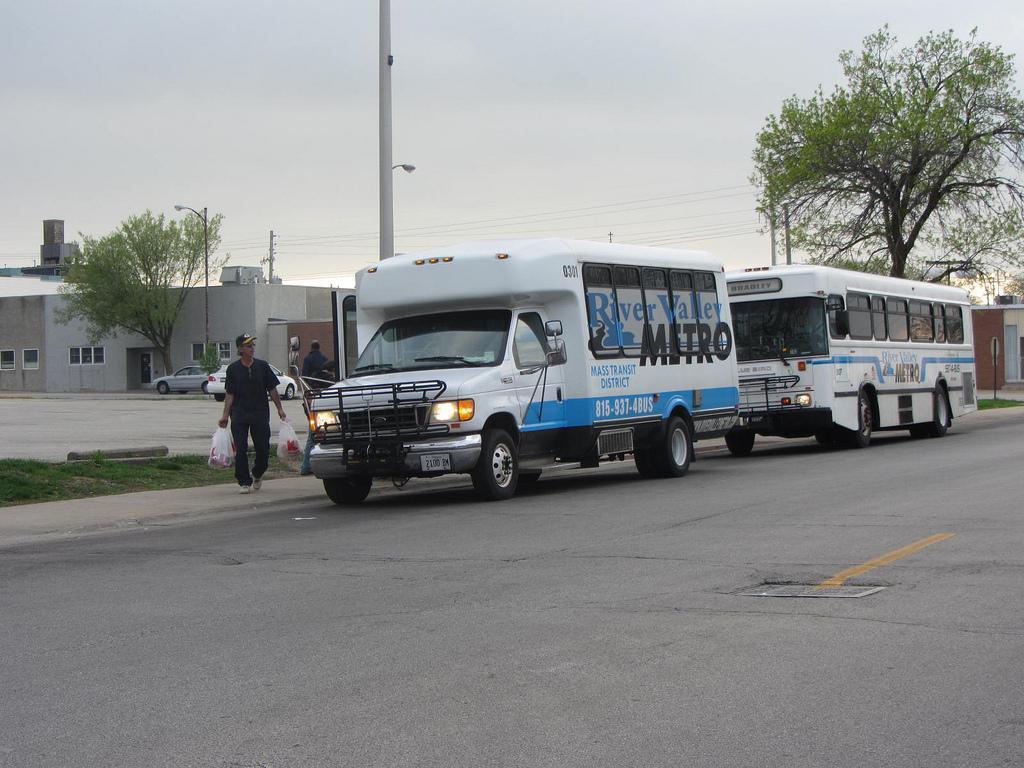How many windows are on the side of the last bus?
Give a very brief answer. 6. How many bags is the man holding?
Give a very brief answer. 2. How many headlights are lite up?
Give a very brief answer. 3. How many vehicles are parked near each other?
Give a very brief answer. 2. How many cars in parking lot?
Give a very brief answer. 2. How many men in black?
Give a very brief answer. 2. How many trees?
Give a very brief answer. 2. How many buses are in the picture?
Give a very brief answer. 2. 